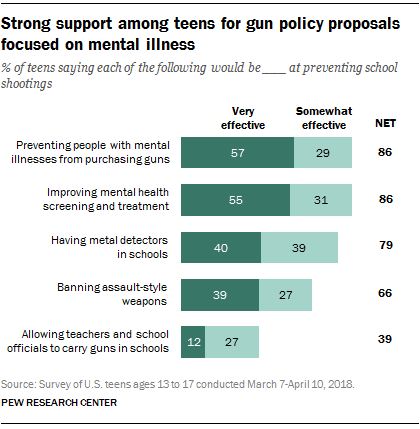Mention a couple of crucial points in this snapshot. A recent survey found that 39% of teenagers believe that banning assault-style weapons is very effective at preventing school shootings. 